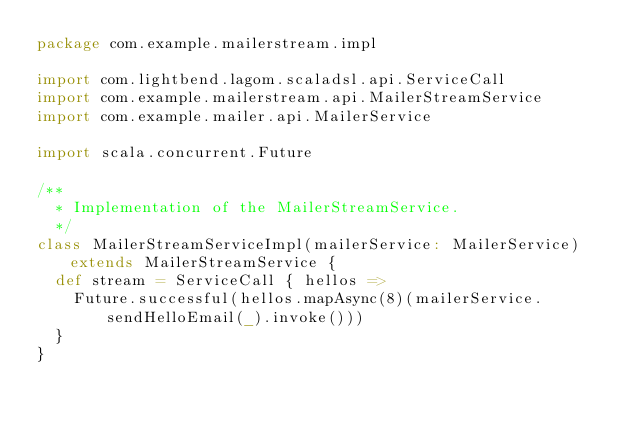<code> <loc_0><loc_0><loc_500><loc_500><_Scala_>package com.example.mailerstream.impl

import com.lightbend.lagom.scaladsl.api.ServiceCall
import com.example.mailerstream.api.MailerStreamService
import com.example.mailer.api.MailerService

import scala.concurrent.Future

/**
  * Implementation of the MailerStreamService.
  */
class MailerStreamServiceImpl(mailerService: MailerService) extends MailerStreamService {
  def stream = ServiceCall { hellos =>
    Future.successful(hellos.mapAsync(8)(mailerService.sendHelloEmail(_).invoke()))
  }
}
</code> 